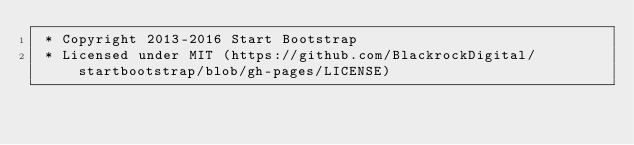<code> <loc_0><loc_0><loc_500><loc_500><_CSS_> * Copyright 2013-2016 Start Bootstrap
 * Licensed under MIT (https://github.com/BlackrockDigital/startbootstrap/blob/gh-pages/LICENSE)</code> 